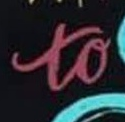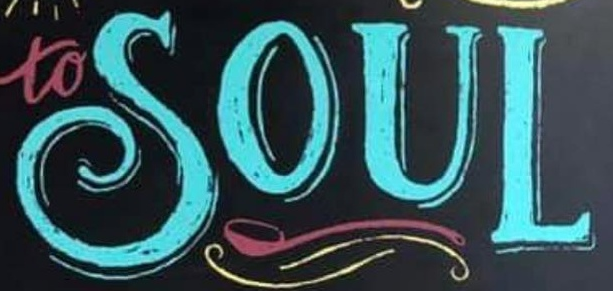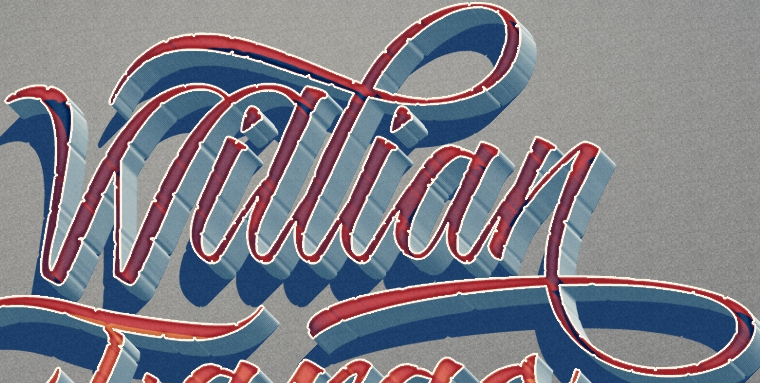Identify the words shown in these images in order, separated by a semicolon. to; SOUL; Willian 